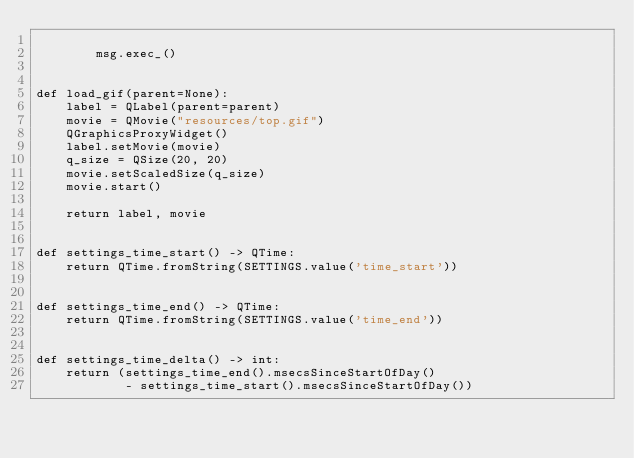Convert code to text. <code><loc_0><loc_0><loc_500><loc_500><_Python_>
        msg.exec_()


def load_gif(parent=None):
    label = QLabel(parent=parent)
    movie = QMovie("resources/top.gif")
    QGraphicsProxyWidget()
    label.setMovie(movie)
    q_size = QSize(20, 20)
    movie.setScaledSize(q_size)
    movie.start()

    return label, movie


def settings_time_start() -> QTime:
    return QTime.fromString(SETTINGS.value('time_start'))


def settings_time_end() -> QTime:
    return QTime.fromString(SETTINGS.value('time_end'))


def settings_time_delta() -> int:
    return (settings_time_end().msecsSinceStartOfDay()
            - settings_time_start().msecsSinceStartOfDay())
</code> 